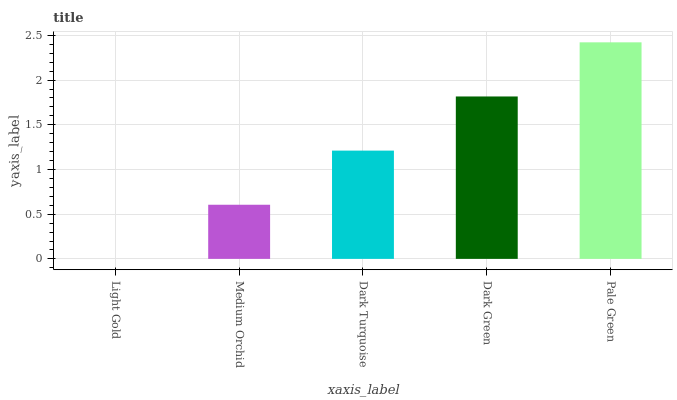Is Light Gold the minimum?
Answer yes or no. Yes. Is Pale Green the maximum?
Answer yes or no. Yes. Is Medium Orchid the minimum?
Answer yes or no. No. Is Medium Orchid the maximum?
Answer yes or no. No. Is Medium Orchid greater than Light Gold?
Answer yes or no. Yes. Is Light Gold less than Medium Orchid?
Answer yes or no. Yes. Is Light Gold greater than Medium Orchid?
Answer yes or no. No. Is Medium Orchid less than Light Gold?
Answer yes or no. No. Is Dark Turquoise the high median?
Answer yes or no. Yes. Is Dark Turquoise the low median?
Answer yes or no. Yes. Is Dark Green the high median?
Answer yes or no. No. Is Pale Green the low median?
Answer yes or no. No. 